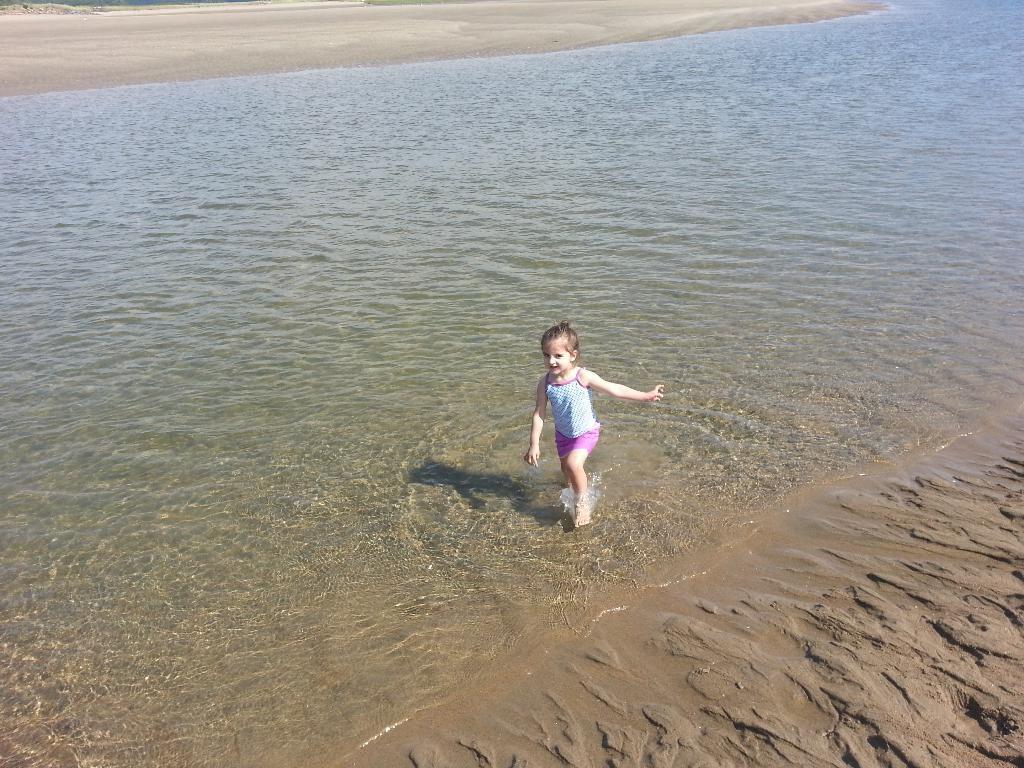Please provide a concise description of this image. In this image I can see the water, a child standing in the water and the sand. In the background I can see the ground. 